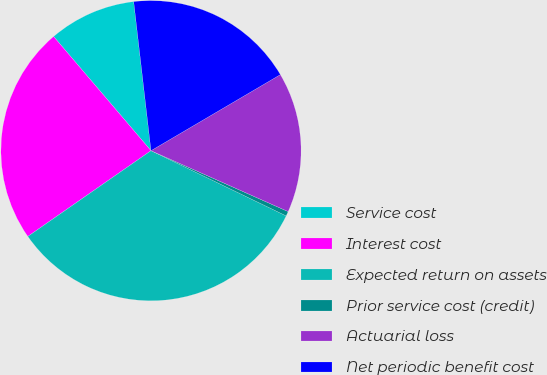Convert chart. <chart><loc_0><loc_0><loc_500><loc_500><pie_chart><fcel>Service cost<fcel>Interest cost<fcel>Expected return on assets<fcel>Prior service cost (credit)<fcel>Actuarial loss<fcel>Net periodic benefit cost<nl><fcel>9.4%<fcel>23.44%<fcel>33.17%<fcel>0.5%<fcel>15.11%<fcel>18.38%<nl></chart> 